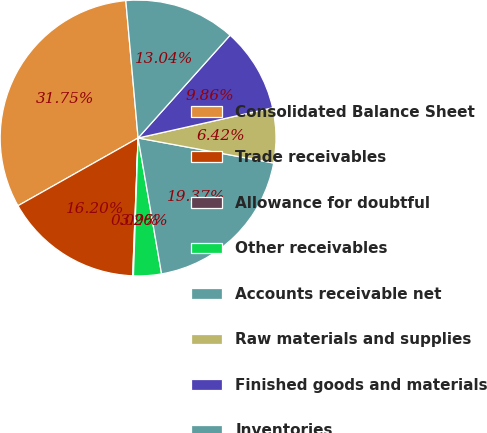Convert chart to OTSL. <chart><loc_0><loc_0><loc_500><loc_500><pie_chart><fcel>Consolidated Balance Sheet<fcel>Trade receivables<fcel>Allowance for doubtful<fcel>Other receivables<fcel>Accounts receivable net<fcel>Raw materials and supplies<fcel>Finished goods and materials<fcel>Inventories<nl><fcel>31.75%<fcel>16.2%<fcel>0.09%<fcel>3.26%<fcel>19.37%<fcel>6.42%<fcel>9.86%<fcel>13.04%<nl></chart> 